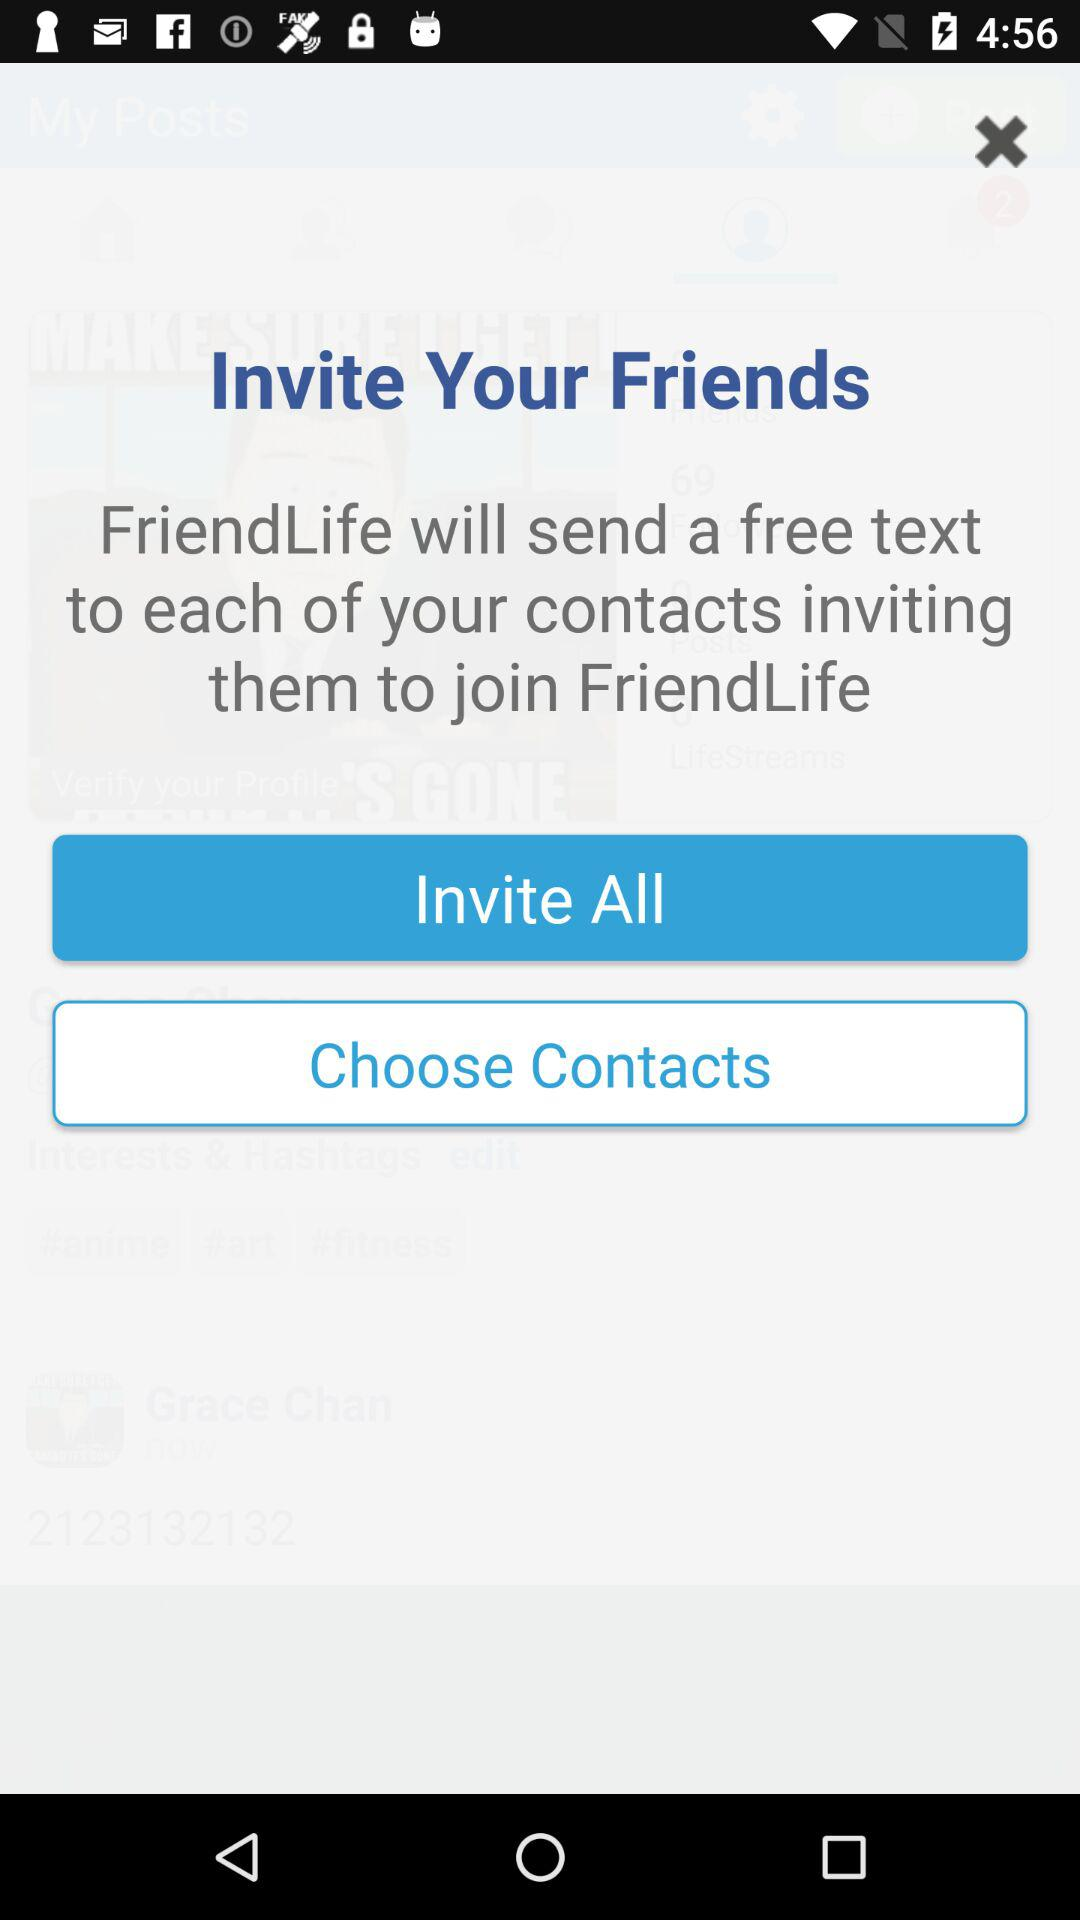Who will send a free text? A free text will be sent by "FriendLife". 